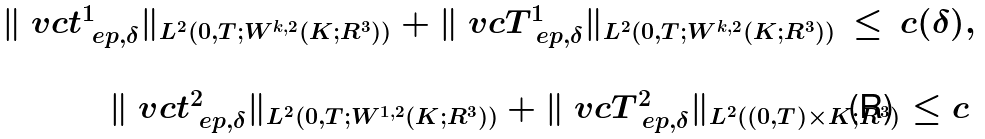<formula> <loc_0><loc_0><loc_500><loc_500>\begin{array} { r } \| \ v c t _ { \ e p , \delta } ^ { 1 } \| _ { L ^ { 2 } ( 0 , T ; W ^ { k , 2 } ( K ; R ^ { 3 } ) ) } + \| \ v c T _ { \ e p , \delta } ^ { 1 } \| _ { L ^ { 2 } ( 0 , T ; W ^ { k , 2 } ( K ; R ^ { 3 } ) ) } \, \leq \, c ( \delta ) , \\ \\ \| \ v c t _ { \ e p , \delta } ^ { 2 } \| _ { L ^ { 2 } ( 0 , T ; W ^ { 1 , 2 } ( K ; R ^ { 3 } ) ) } + \| \ v c T _ { \ e p , \delta } ^ { 2 } \| _ { L ^ { 2 } ( ( 0 , T ) \times K ; R ^ { 3 } ) } \leq c \, \end{array}</formula> 